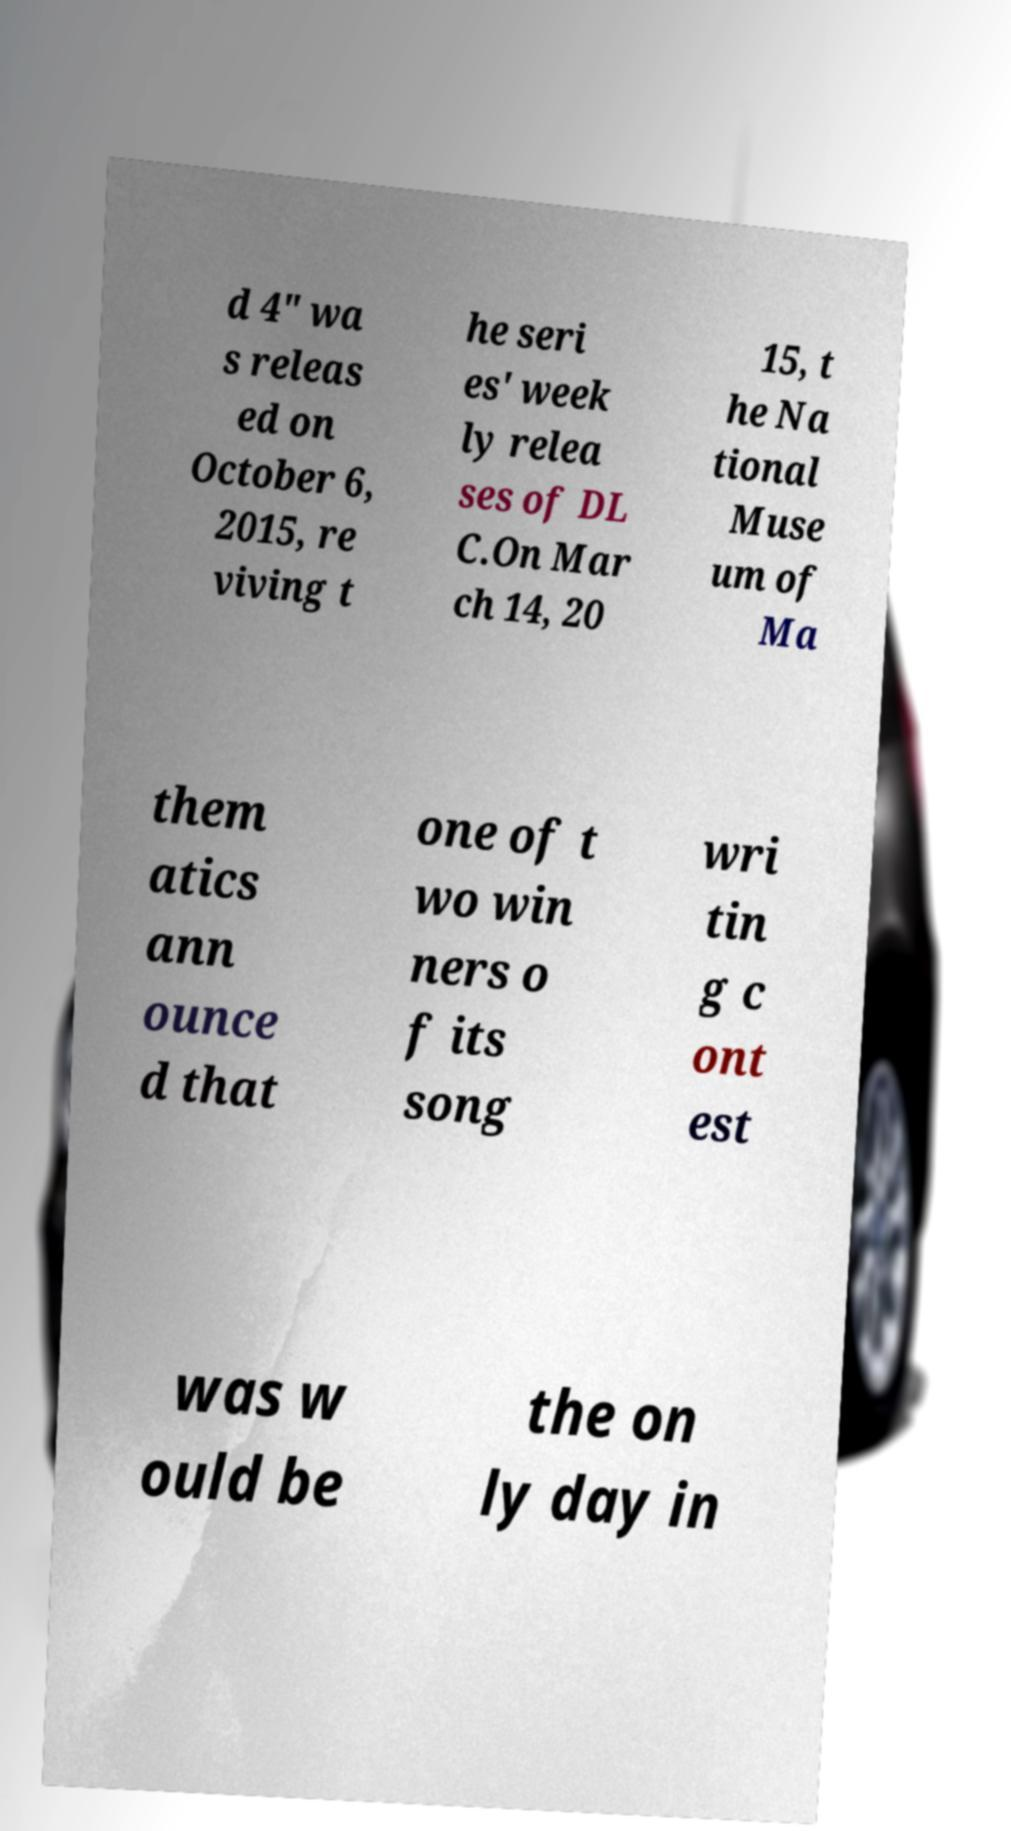Please read and relay the text visible in this image. What does it say? d 4" wa s releas ed on October 6, 2015, re viving t he seri es' week ly relea ses of DL C.On Mar ch 14, 20 15, t he Na tional Muse um of Ma them atics ann ounce d that one of t wo win ners o f its song wri tin g c ont est was w ould be the on ly day in 